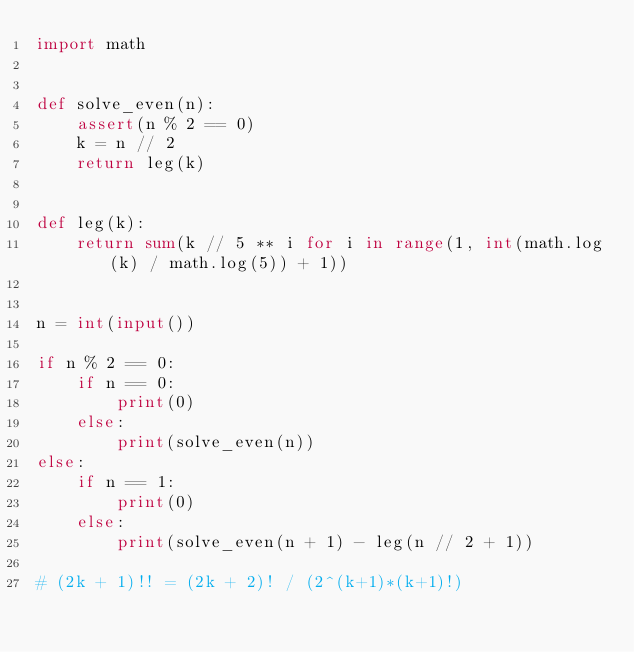Convert code to text. <code><loc_0><loc_0><loc_500><loc_500><_Python_>import math


def solve_even(n):
    assert(n % 2 == 0)
    k = n // 2
    return leg(k)


def leg(k):
    return sum(k // 5 ** i for i in range(1, int(math.log(k) / math.log(5)) + 1))


n = int(input())

if n % 2 == 0:
    if n == 0:
        print(0)
    else:
        print(solve_even(n))
else:
    if n == 1:
        print(0)
    else:
        print(solve_even(n + 1) - leg(n // 2 + 1))

# (2k + 1)!! = (2k + 2)! / (2^(k+1)*(k+1)!)
</code> 